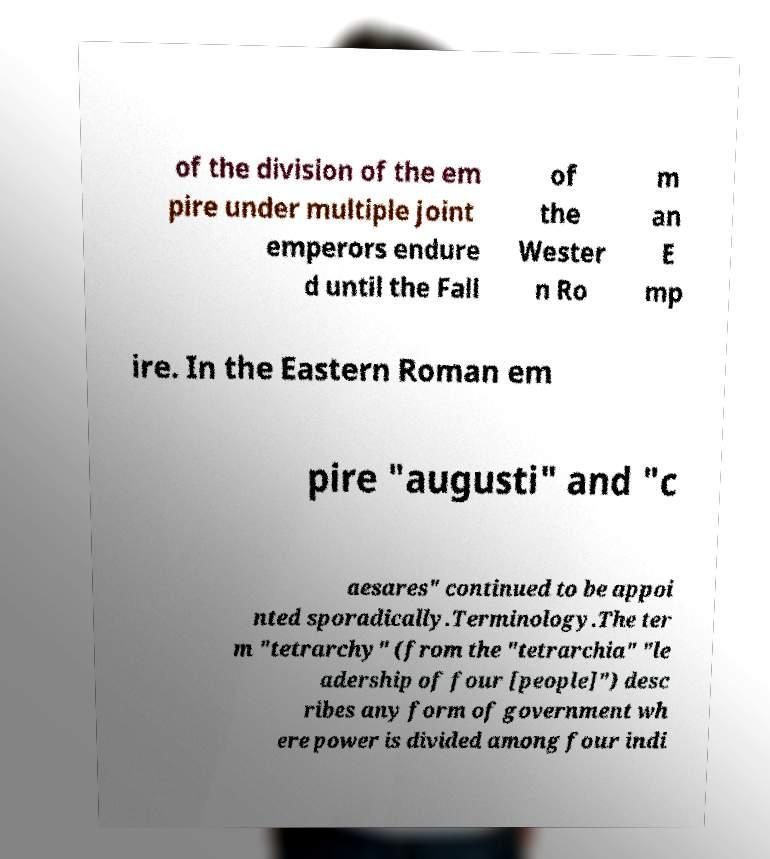Please read and relay the text visible in this image. What does it say? of the division of the em pire under multiple joint emperors endure d until the Fall of the Wester n Ro m an E mp ire. In the Eastern Roman em pire "augusti" and "c aesares" continued to be appoi nted sporadically.Terminology.The ter m "tetrarchy" (from the "tetrarchia" "le adership of four [people]") desc ribes any form of government wh ere power is divided among four indi 